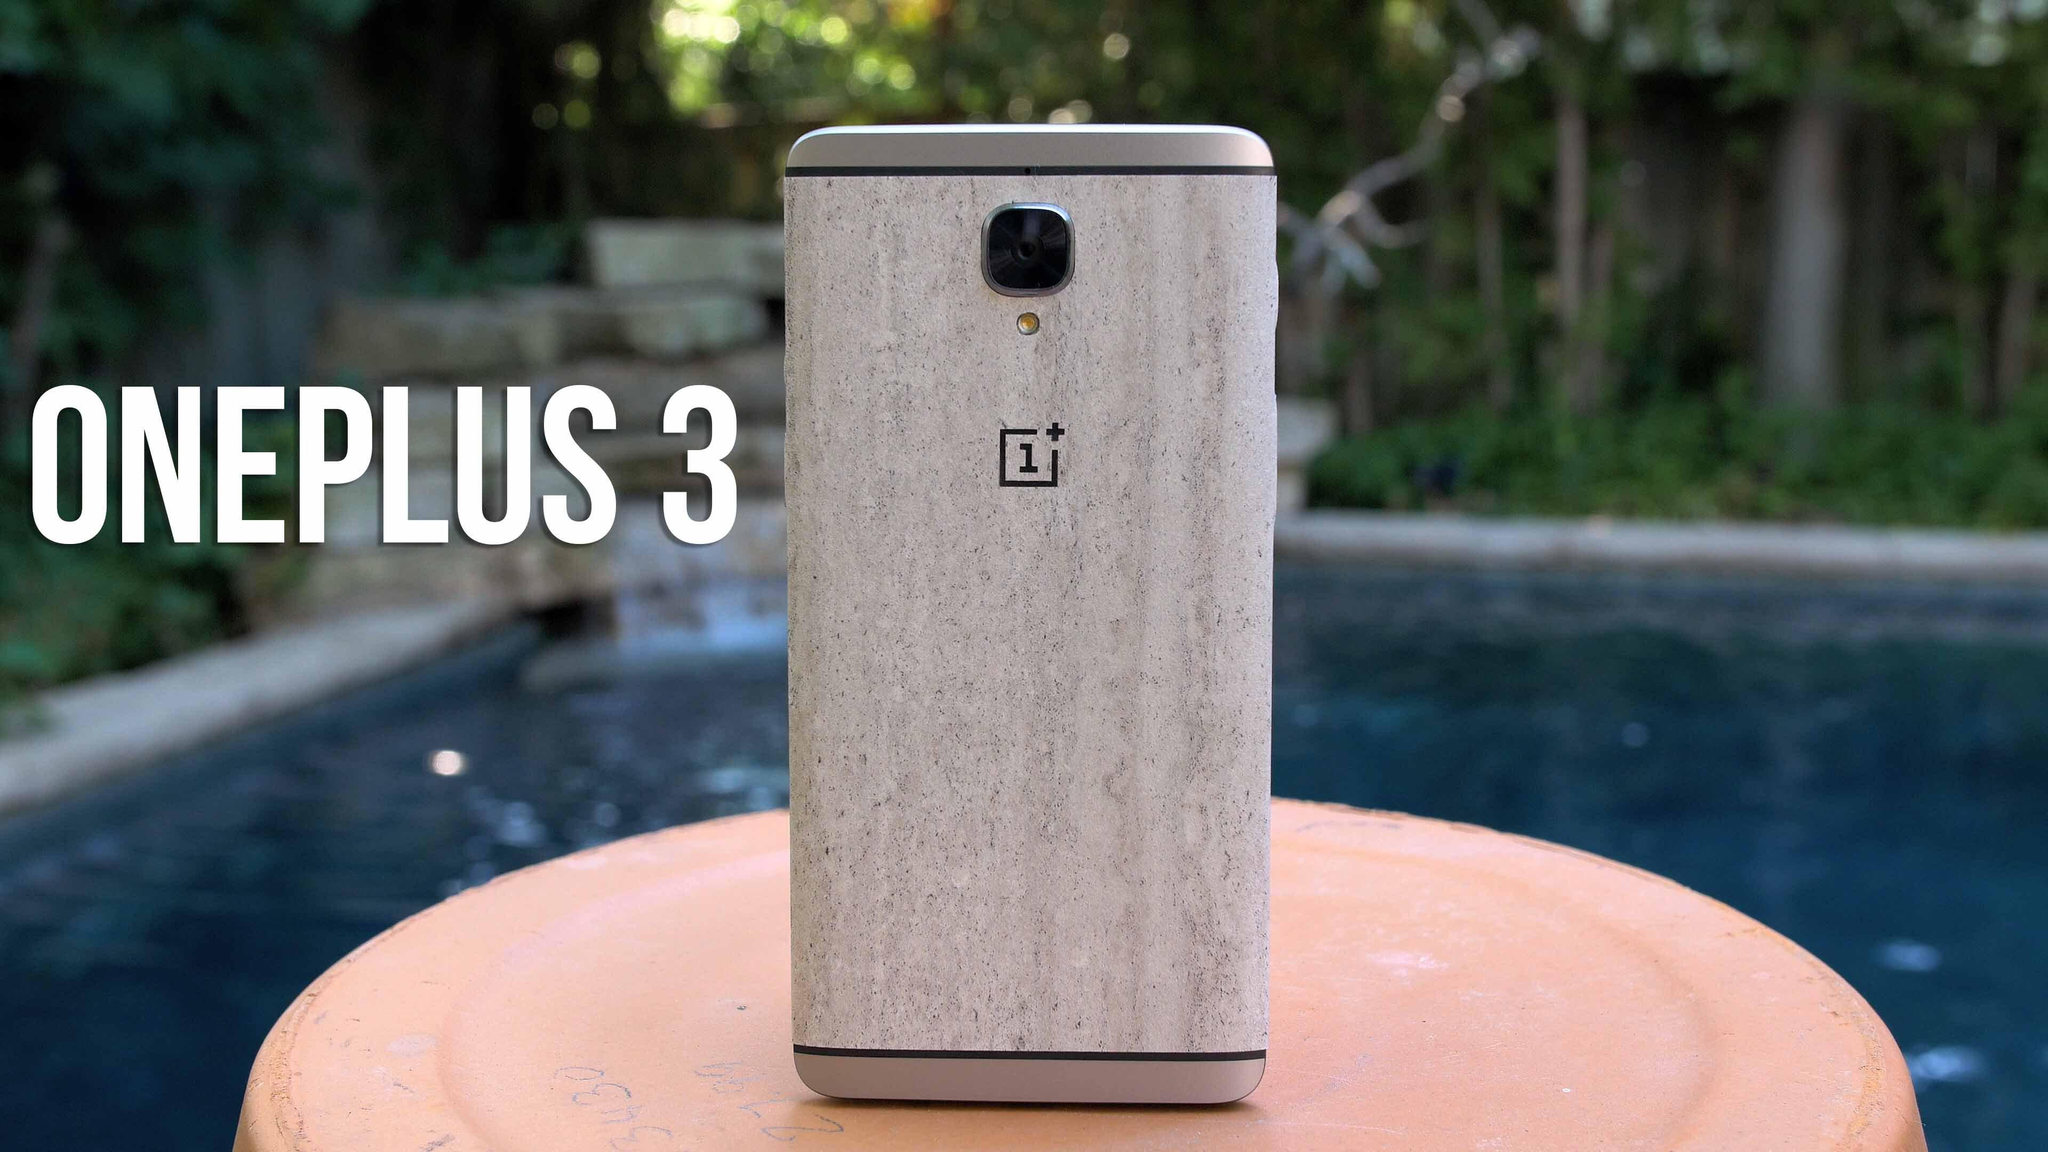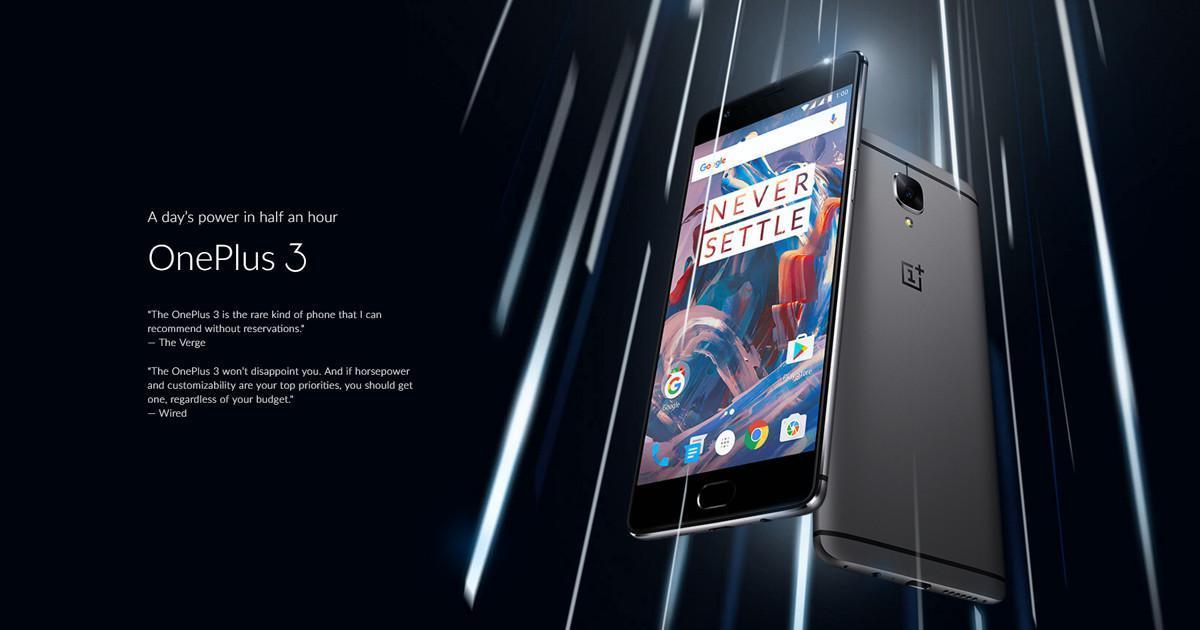The first image is the image on the left, the second image is the image on the right. Evaluate the accuracy of this statement regarding the images: "A person is holding the phone in the image on the right.". Is it true? Answer yes or no. No. The first image is the image on the left, the second image is the image on the right. Evaluate the accuracy of this statement regarding the images: "The right image shows a hand holding a rectangular screen-front device angled to the left.". Is it true? Answer yes or no. No. 